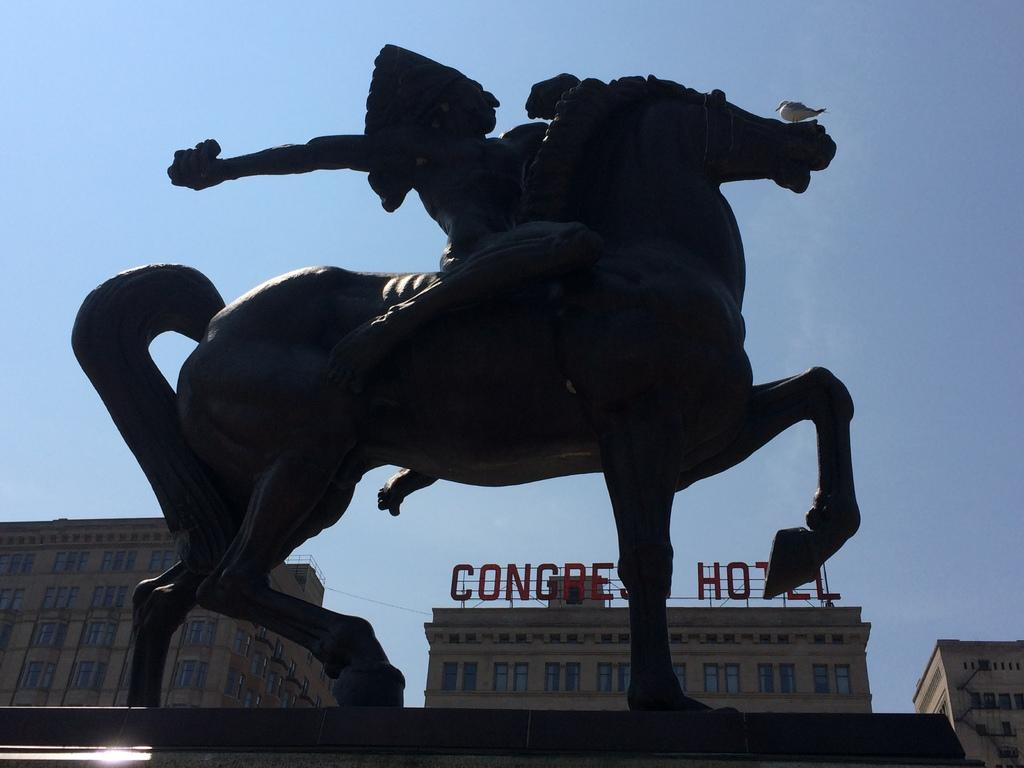What can be seen in the background of the image? There is sky visible in the image. What is the main subject in the image? There is a statue in the image. What type of structures are present in the image? There are buildings in the image. What is the statue standing on? There is a pedestal in the image. What is the rate of cattle grazing in the image? There are no cattle present in the image, so it is not possible to determine the rate of grazing. 